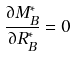<formula> <loc_0><loc_0><loc_500><loc_500>\frac { \partial M _ { B } ^ { * } } { \partial R _ { B } ^ { * } } = 0</formula> 